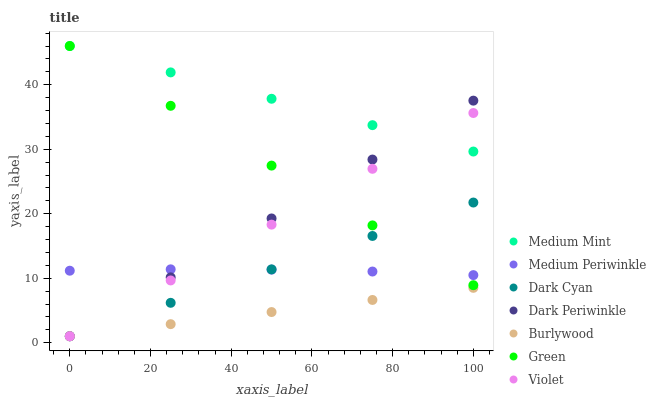Does Burlywood have the minimum area under the curve?
Answer yes or no. Yes. Does Medium Mint have the maximum area under the curve?
Answer yes or no. Yes. Does Medium Periwinkle have the minimum area under the curve?
Answer yes or no. No. Does Medium Periwinkle have the maximum area under the curve?
Answer yes or no. No. Is Burlywood the smoothest?
Answer yes or no. Yes. Is Medium Periwinkle the roughest?
Answer yes or no. Yes. Is Medium Periwinkle the smoothest?
Answer yes or no. No. Is Burlywood the roughest?
Answer yes or no. No. Does Burlywood have the lowest value?
Answer yes or no. Yes. Does Medium Periwinkle have the lowest value?
Answer yes or no. No. Does Green have the highest value?
Answer yes or no. Yes. Does Medium Periwinkle have the highest value?
Answer yes or no. No. Is Burlywood less than Medium Periwinkle?
Answer yes or no. Yes. Is Green greater than Burlywood?
Answer yes or no. Yes. Does Violet intersect Dark Cyan?
Answer yes or no. Yes. Is Violet less than Dark Cyan?
Answer yes or no. No. Is Violet greater than Dark Cyan?
Answer yes or no. No. Does Burlywood intersect Medium Periwinkle?
Answer yes or no. No. 